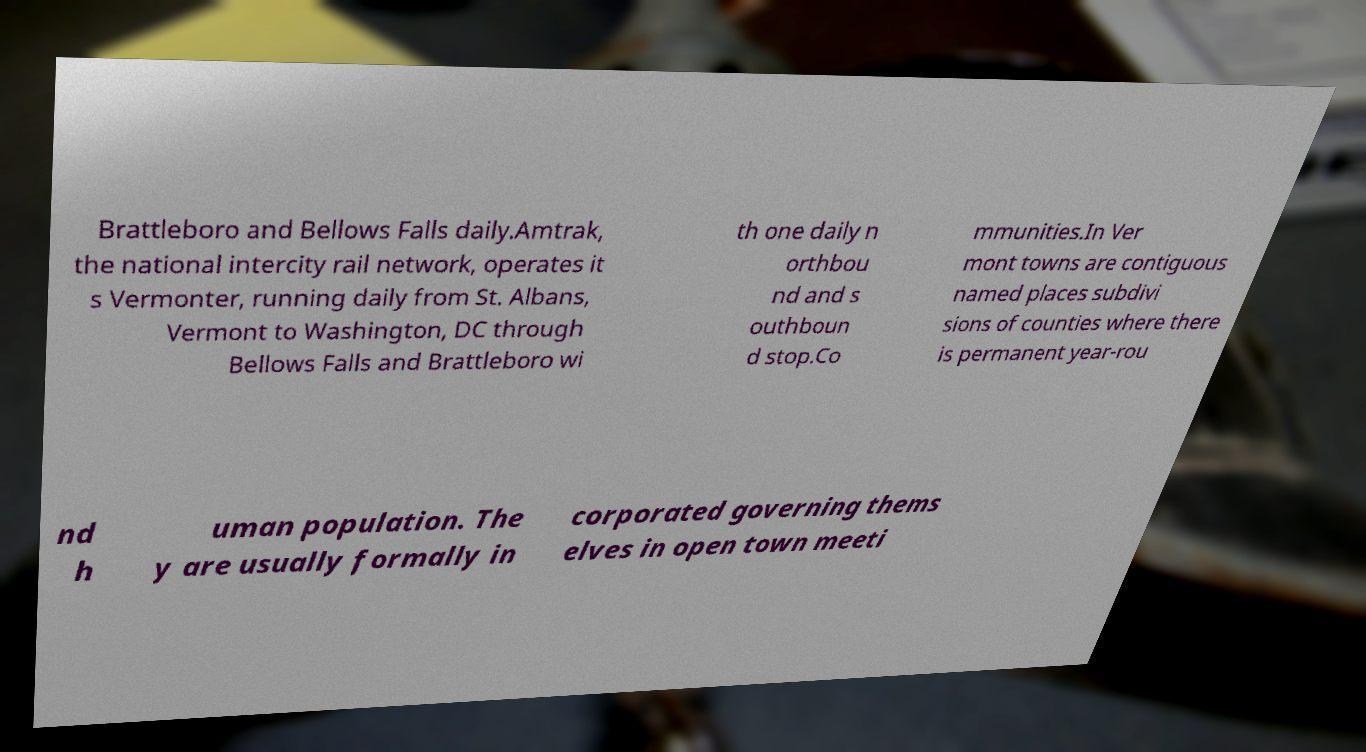What messages or text are displayed in this image? I need them in a readable, typed format. Brattleboro and Bellows Falls daily.Amtrak, the national intercity rail network, operates it s Vermonter, running daily from St. Albans, Vermont to Washington, DC through Bellows Falls and Brattleboro wi th one daily n orthbou nd and s outhboun d stop.Co mmunities.In Ver mont towns are contiguous named places subdivi sions of counties where there is permanent year-rou nd h uman population. The y are usually formally in corporated governing thems elves in open town meeti 